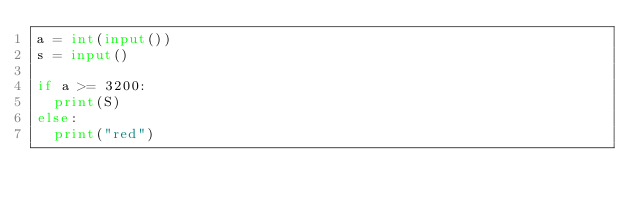<code> <loc_0><loc_0><loc_500><loc_500><_Python_>a = int(input())
s = input()

if a >= 3200:
  print(S)
else:
  print("red")</code> 